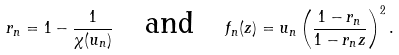Convert formula to latex. <formula><loc_0><loc_0><loc_500><loc_500>r _ { n } = 1 - \frac { 1 } { \chi ( u _ { n } ) } \quad \text {and} \quad f _ { n } ( z ) = u _ { n } \left ( \frac { 1 - r _ { n } } { 1 - r _ { n } z } \right ) ^ { 2 } .</formula> 